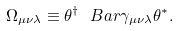<formula> <loc_0><loc_0><loc_500><loc_500>\Omega _ { \mu \nu \lambda } \equiv \theta ^ { \dagger } \ B a r \gamma _ { \mu \nu \lambda } \theta ^ { * } .</formula> 